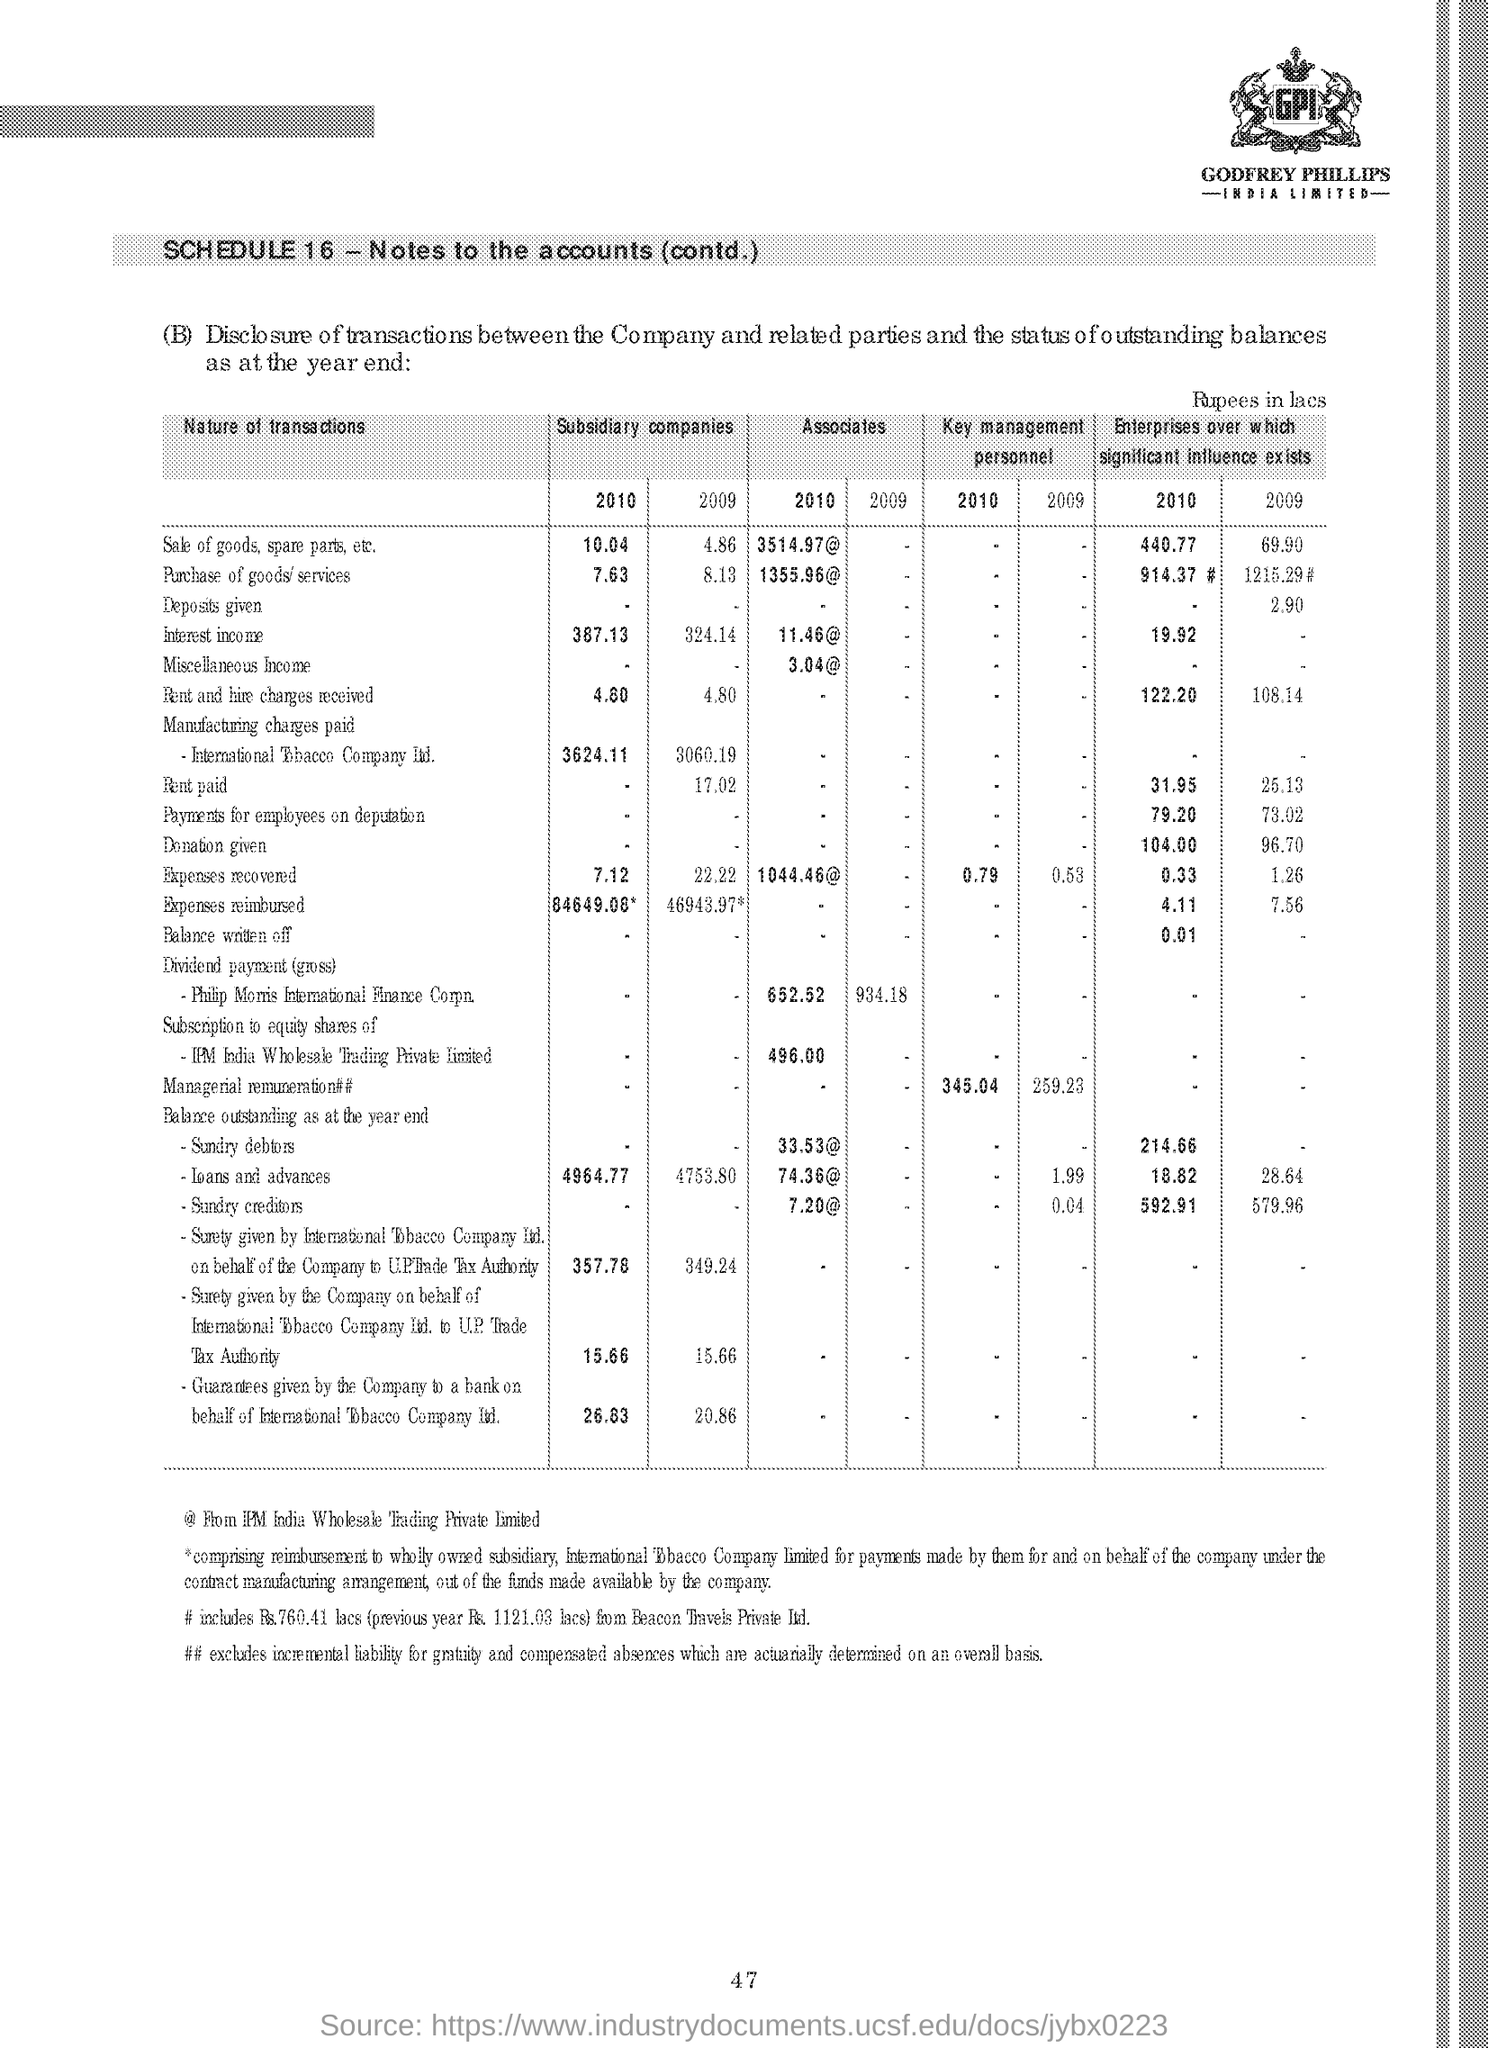What was the total dividends paid by the company in 2010, and was there a difference from the previous year? The total dividend payment (gross) made by the company in 2010 was 652.52 crore, which shows an increase from the 2009 figure of 934.18 crore. It seems there is a decrease. Can you explain why the dividends in 2010 were lower than in 2009? A decrease in dividends can result from various factors including a change in the company's dividend policy, the need to retain earnings to finance growth, or lower profits. Specific details would require further analysis of the company's financial performance and decisions in that fiscal year. 